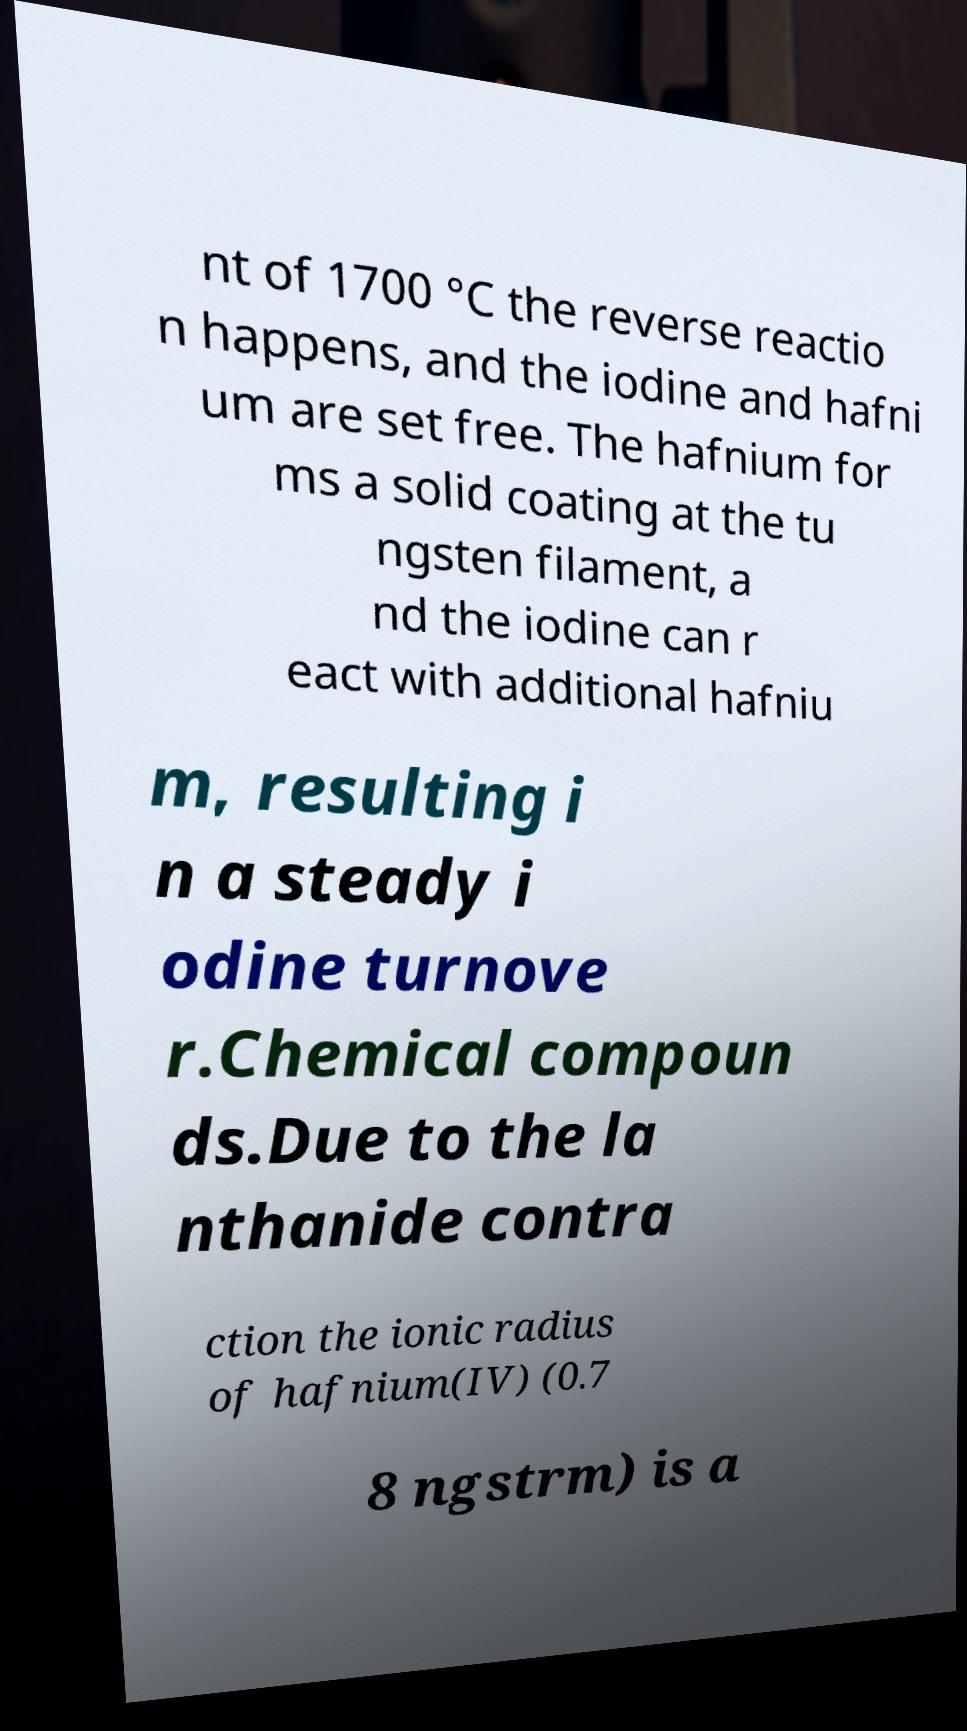Please read and relay the text visible in this image. What does it say? nt of 1700 °C the reverse reactio n happens, and the iodine and hafni um are set free. The hafnium for ms a solid coating at the tu ngsten filament, a nd the iodine can r eact with additional hafniu m, resulting i n a steady i odine turnove r.Chemical compoun ds.Due to the la nthanide contra ction the ionic radius of hafnium(IV) (0.7 8 ngstrm) is a 